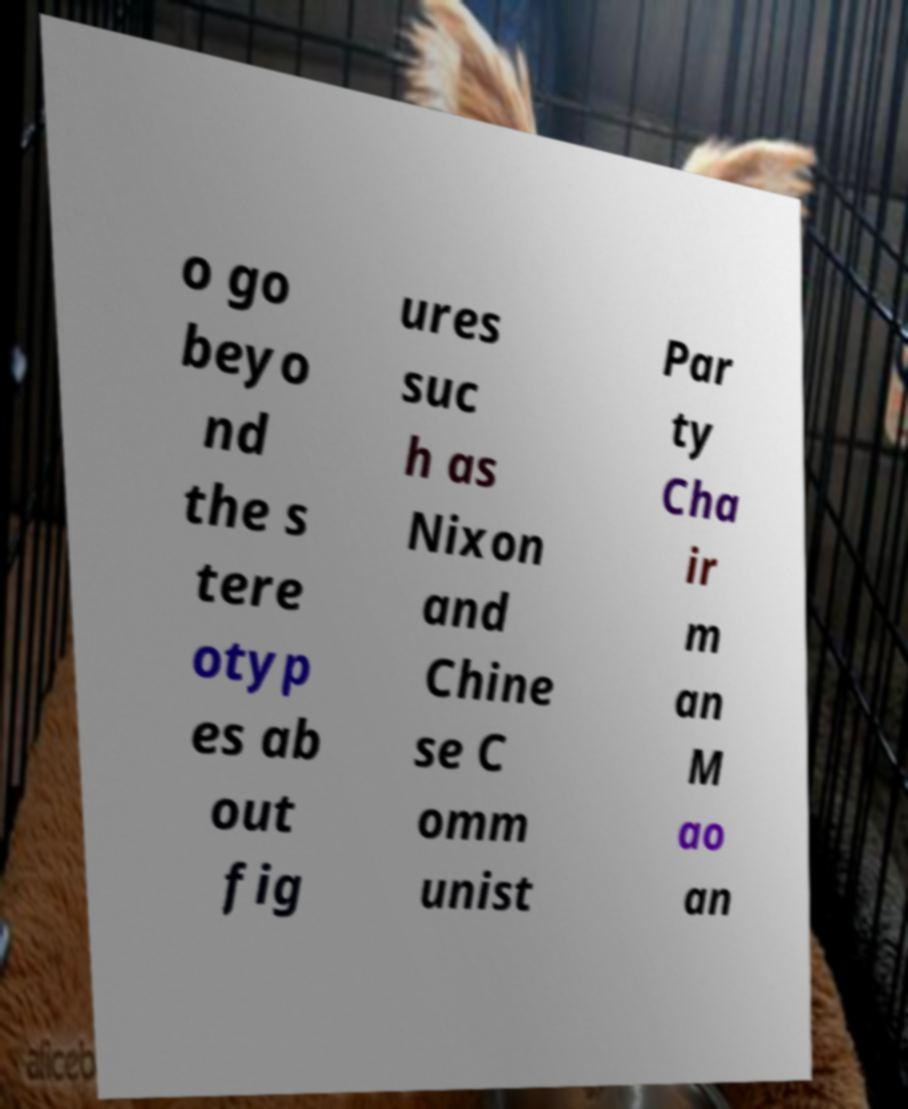Please identify and transcribe the text found in this image. o go beyo nd the s tere otyp es ab out fig ures suc h as Nixon and Chine se C omm unist Par ty Cha ir m an M ao an 